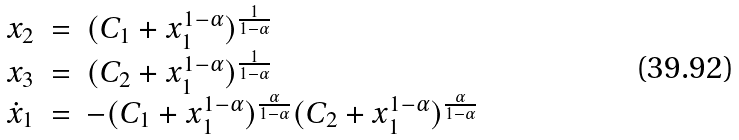Convert formula to latex. <formula><loc_0><loc_0><loc_500><loc_500>\begin{array} { l l l } x _ { 2 } & = & ( C _ { 1 } + x _ { 1 } ^ { 1 - \alpha } ) ^ { \frac { 1 } { 1 - \alpha } } \\ x _ { 3 } & = & ( C _ { 2 } + x _ { 1 } ^ { 1 - \alpha } ) ^ { \frac { 1 } { 1 - \alpha } } \\ \dot { x } _ { 1 } & = & - ( C _ { 1 } + x _ { 1 } ^ { 1 - \alpha } ) ^ { \frac { \alpha } { 1 - \alpha } } ( C _ { 2 } + x _ { 1 } ^ { 1 - \alpha } ) ^ { \frac { \alpha } { 1 - \alpha } } \\ \end{array}</formula> 